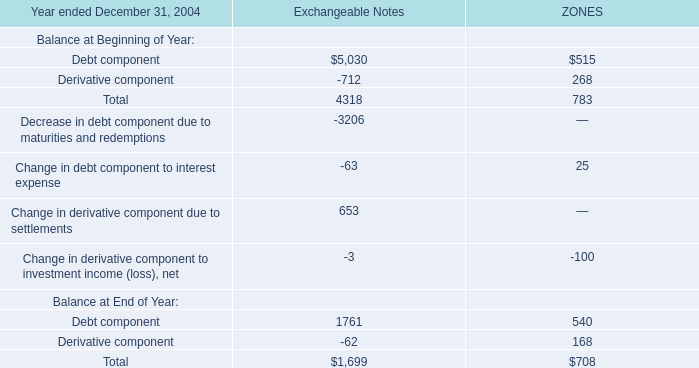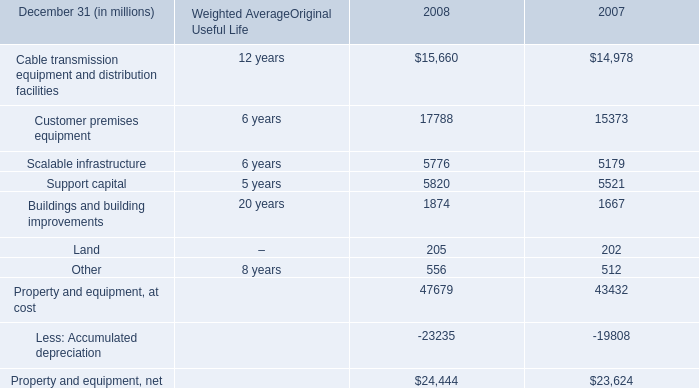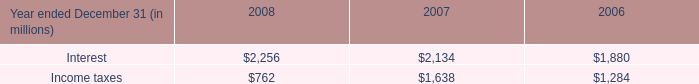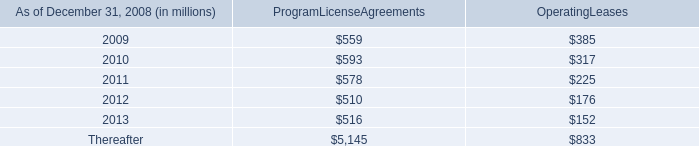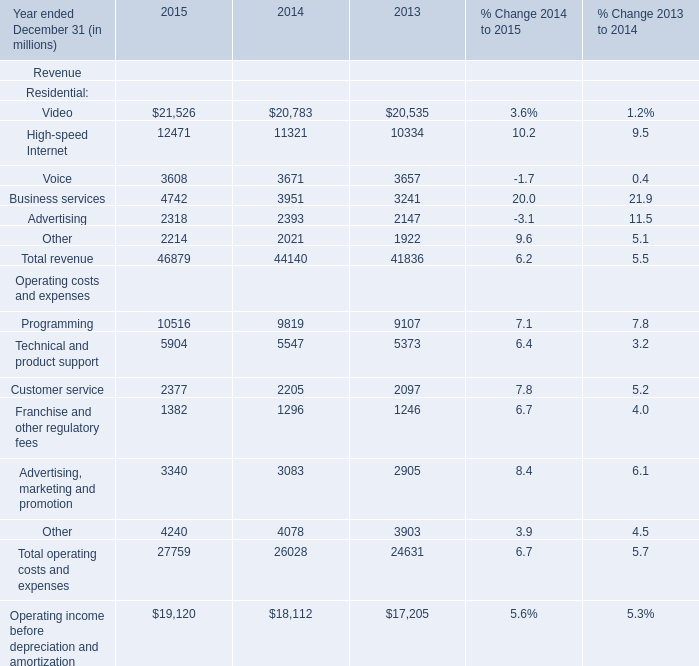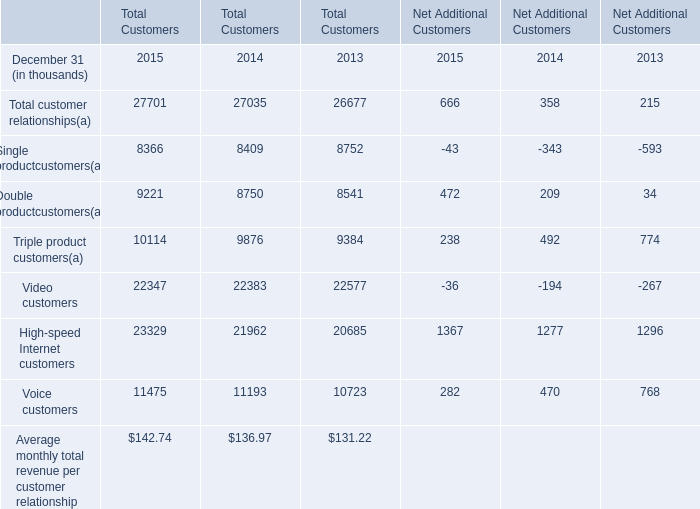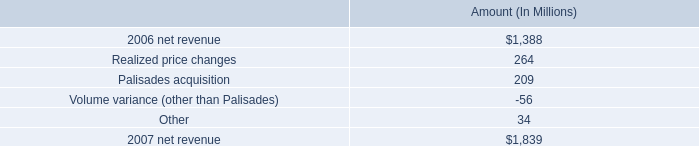based on the analysis of the change in net revenue what was the percent of the annual change in net revenue sourced from realized price changes 
Computations: (264 / 451)
Answer: 0.58537. 